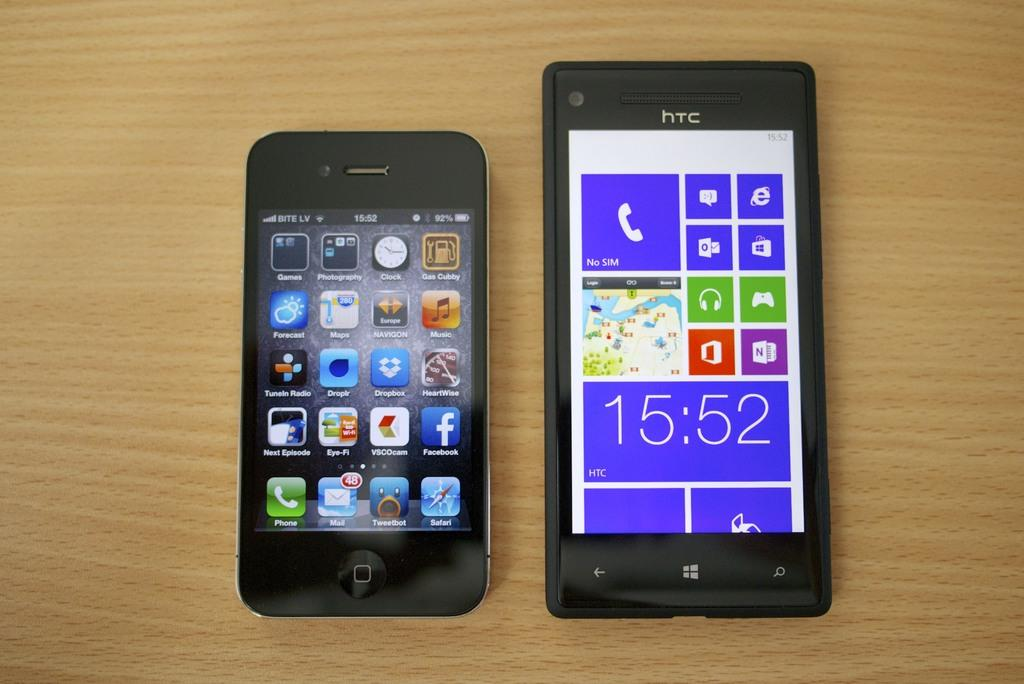<image>
Give a short and clear explanation of the subsequent image. The black phone shown on the right is made by HTC. 